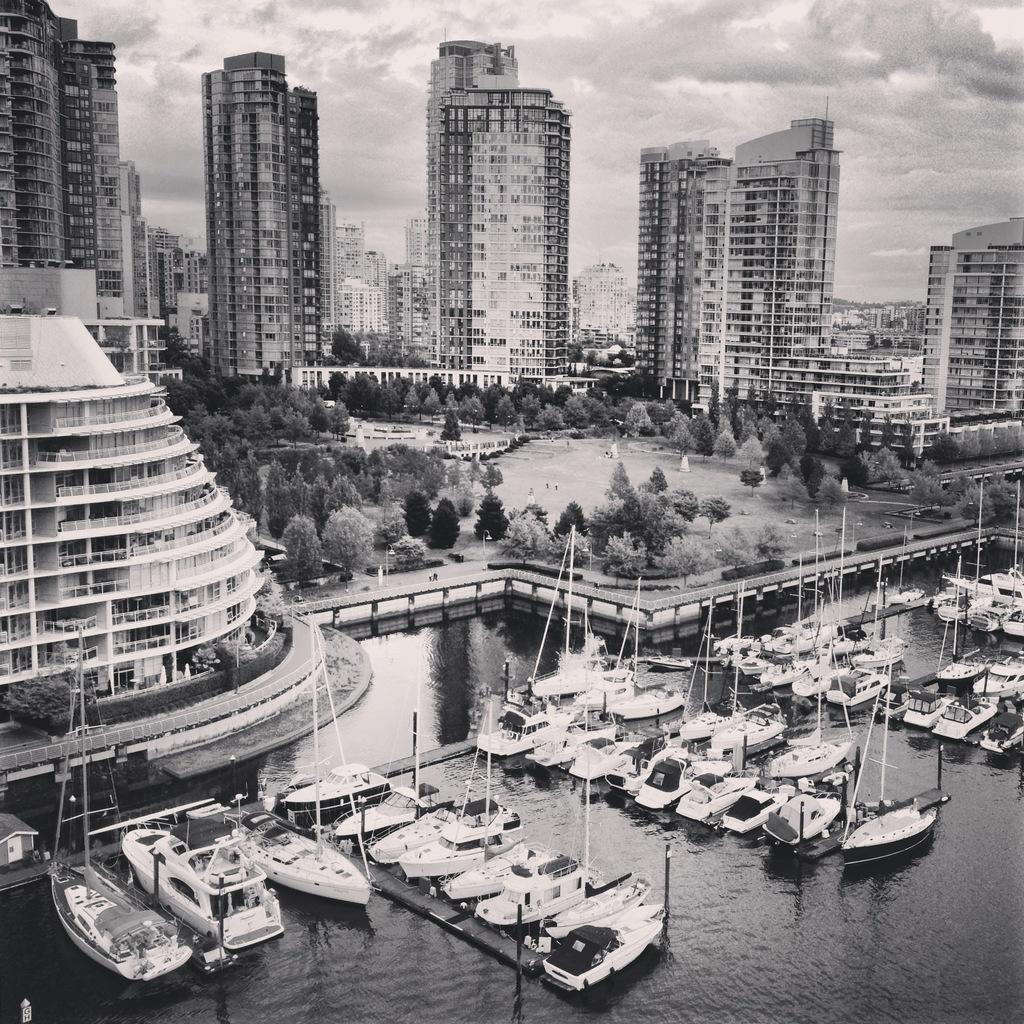What type of structures can be seen in the image? There are many buildings in the image. What other natural elements are present in the image? There are trees in the image. What can be seen in the water in the image? There are ships in the water in the image. From what perspective was the image taken? The image is taken from a top view. How does the thumb perform magic tricks in the image? There is no thumb or magic tricks present in the image. 